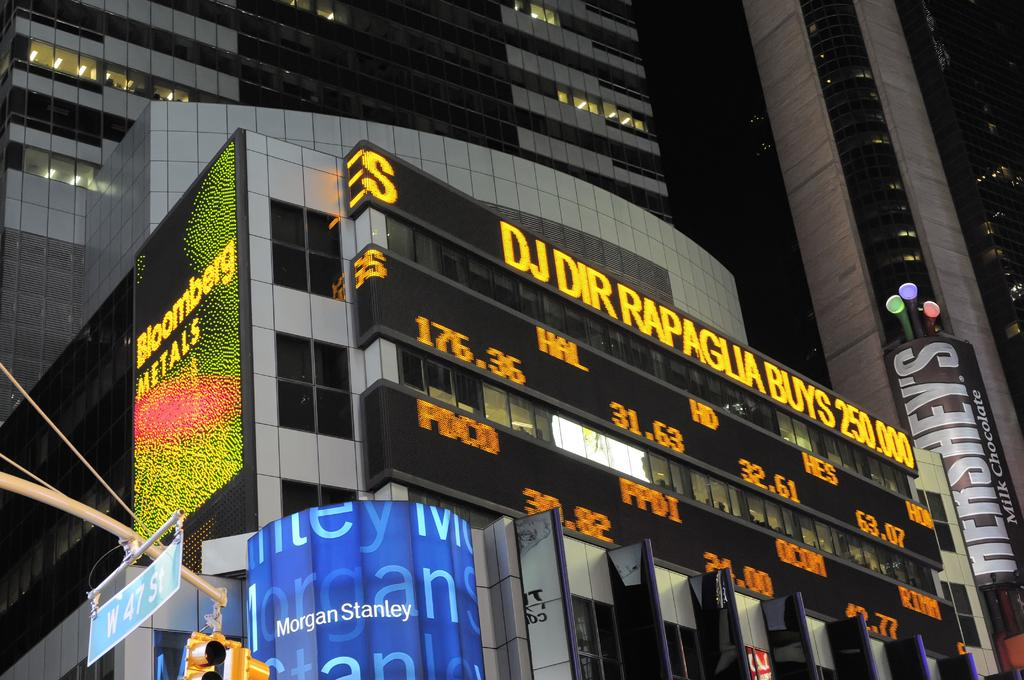What type of structures are present in the image? There are buildings in the image. What can be seen on the buildings? There are digital boards on the buildings. What other objects are visible in the image? There are hoardings and signboards in the image. What might help control traffic in the image? There are signal lights in the image. Can you tell me how many roses are on the digital boards in the image? There are no roses present on the digital boards in the image. What fictional character can be seen on the signboards in the image? There is no fictional character depicted on the signboards in the image. 